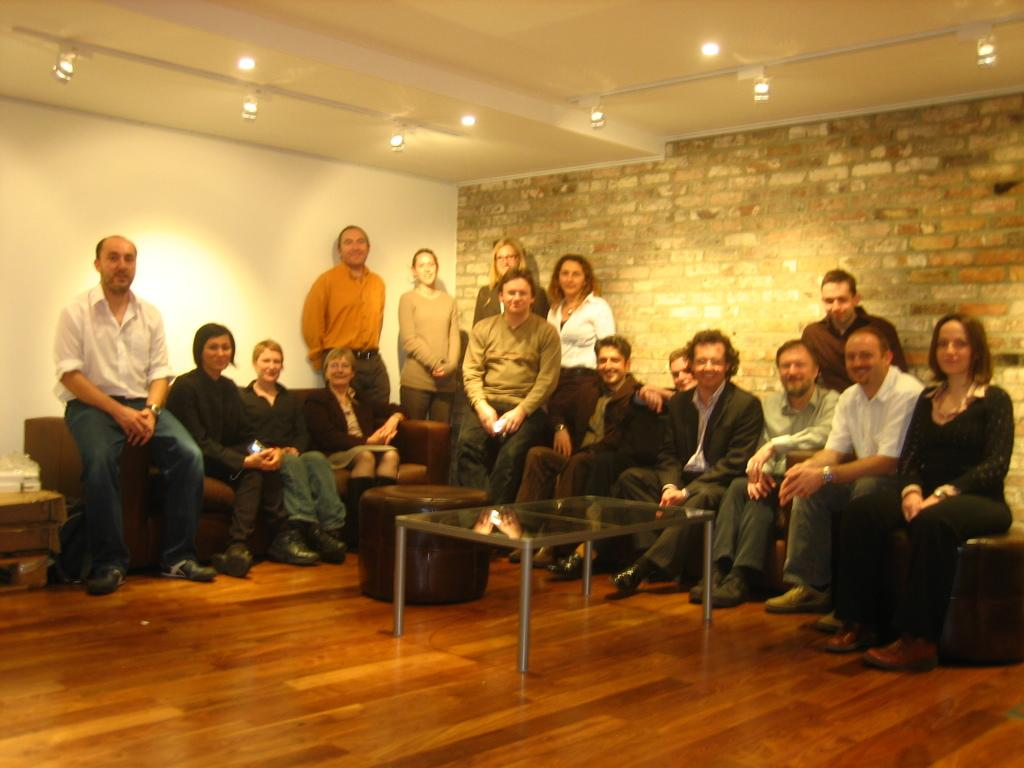What are the people in the image doing? There are persons sitting and standing in the image. What type of furniture is present in the image? There are sofa chairs in the image. What is on the floor in the image? There is a table on the floor in the image. What can be seen in the background of the image? There is a wall in the background of the image. What is visible at the top of the image? There are lights visible at the top of the image. What type of religious advice can be heard in the image? There is no indication of any religious discussion or advice in the image. 